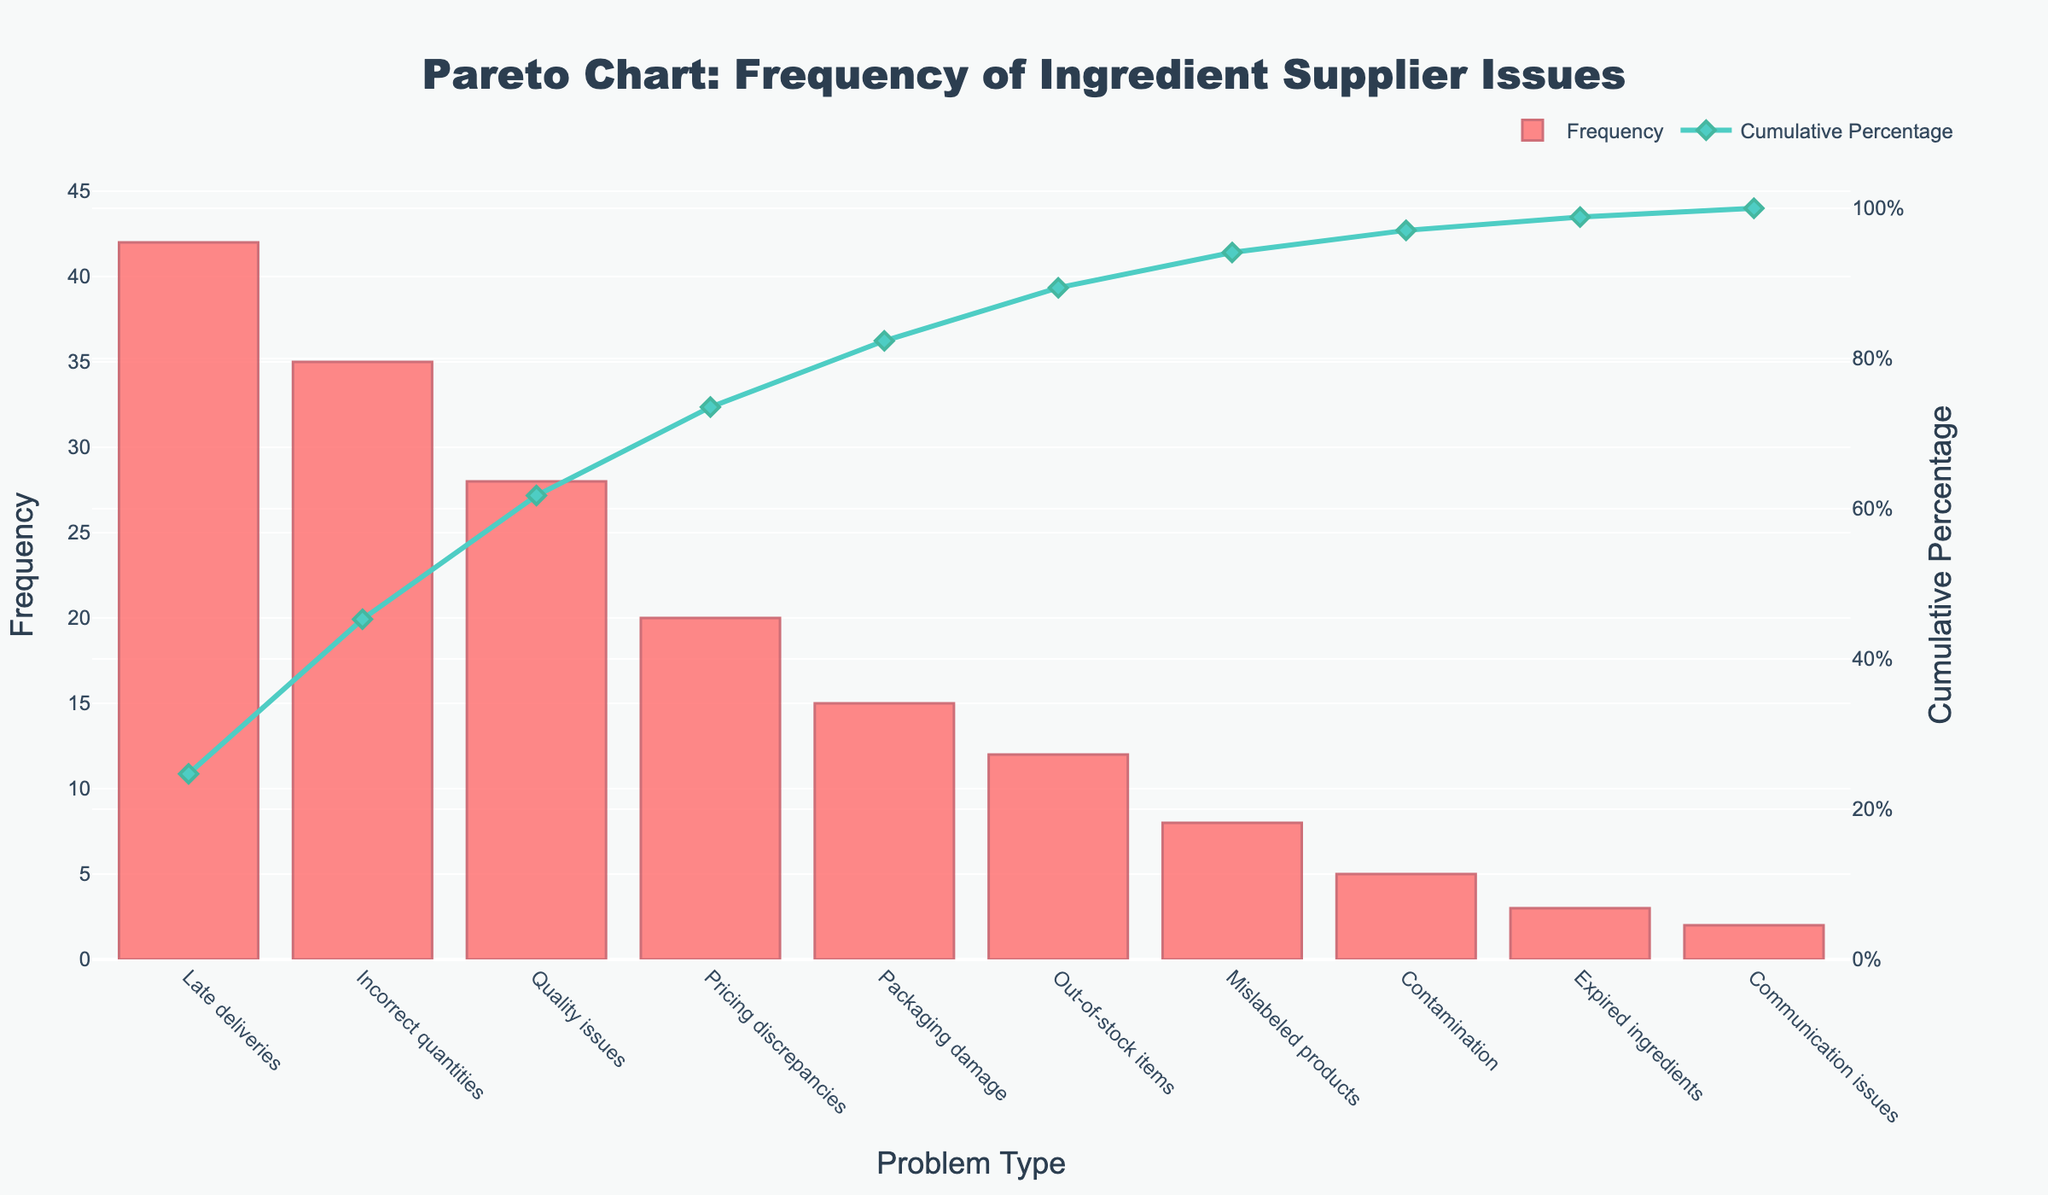What's the title of the figure? The title of the figure is displayed at the center top of the plot. It helps identify the main subject of the chart, which in this case is about ingredient supplier issues.
Answer: Pareto Chart: Frequency of Ingredient Supplier Issues Which problem type has the highest frequency? The highest bar in the bar chart represents the problem type with the highest frequency.
Answer: Late deliveries What is the cumulative percentage for "Quality issues"? Identify the "Quality issues" on the x-axis, then look at the corresponding point on the cumulative percentage line (marked with a diamond symbol).
Answer: Approximately 67% What is the combined frequency of "Incorrect quantities" and "Pricing discrepancies"? Find the frequencies for "Incorrect quantities" (35) and "Pricing discrepancies" (20), then add them together.
Answer: 55 How does the frequency of "Packaging damage" compare to "Out-of-stock items"? Locate the bars for both "Packaging damage" and "Out-of-stock items". Compare their heights to see which one is taller.
Answer: Packaging damage is higher What cumulative percentage is reached by the top three problem types? Sum up the frequencies of the top three problem types (Late deliveries, Incorrect quantities, Quality issues), divide by the total frequency, and multiply by 100.
Answer: Approximately 63% Is the frequency of "Mislabeled products" higher or lower than "Contamination"? Compare the bar heights for "Mislabeled products" and "Contamination".
Answer: Higher What proportion of the total issues is accounted for by "Expired ingredients" and "Communication issues"? Add the frequencies of "Expired ingredients" (3) and "Communication issues" (2), then divide by the total frequency, and multiply by 100.
Answer: Approximately 4.3% Which problem types account for more than 80% of the cumulative percentage? Look at the cumulative percentage line. Identify the point where it exceeds 80% and list the problem types before this point.
Answer: Late deliveries, Incorrect quantities, Quality issues, Pricing discrepancies, Packaging damage What is the frequency of the least common issue and what is the cumulative percentage at this point? Identify the shortest bar on the chart, which represents the least common issue. Note its frequency and check the cumulative percentage corresponding to its position on the line chart.
Answer: Frequency is 2, and cumulative percentage is about 98% 